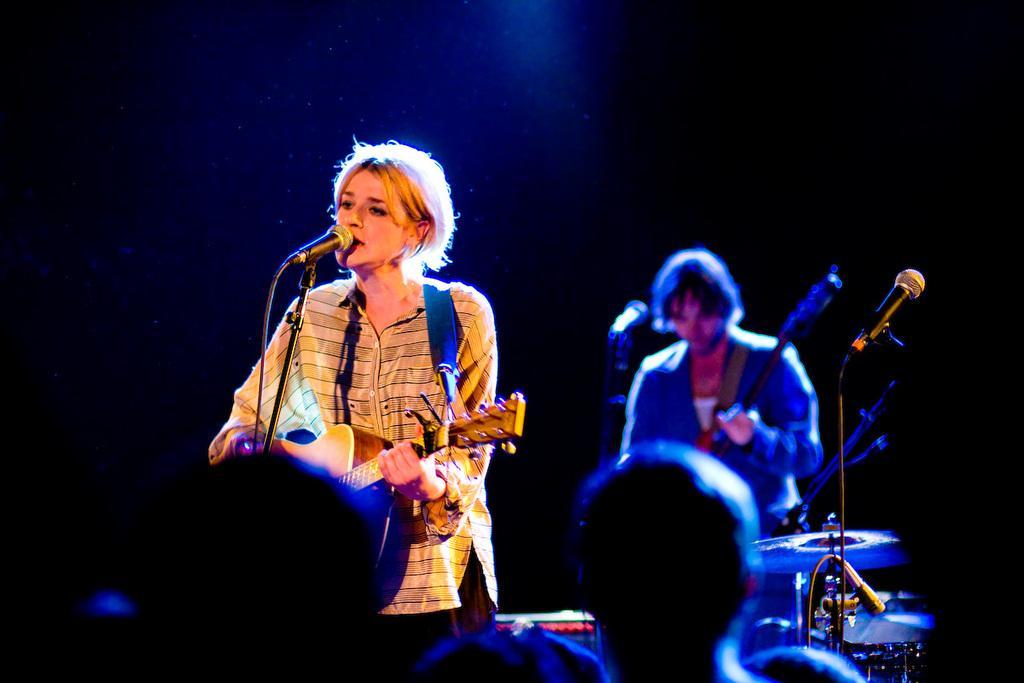Can you describe this image briefly? In this picture we can see woman singing on mic playing guitar and at back of her man playing guitar and in front of them we can see some people. 